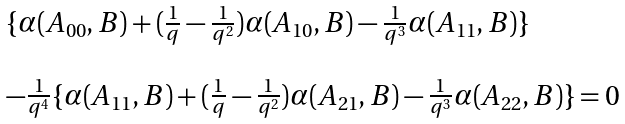<formula> <loc_0><loc_0><loc_500><loc_500>\begin{array} { l } \{ \alpha ( A _ { 0 0 } , B ) + ( \frac { 1 } { q } - \frac { 1 } { q ^ { 2 } } ) \alpha ( A _ { 1 0 } , B ) - \frac { 1 } { q ^ { 3 } } \alpha ( A _ { 1 1 } , B ) \} \\ \\ - \frac { 1 } { q ^ { 4 } } \{ \alpha ( A _ { 1 1 } , B ) + ( \frac { 1 } { q } - \frac { 1 } { q ^ { 2 } } ) \alpha ( A _ { 2 1 } , B ) - \frac { 1 } { q ^ { 3 } } \alpha ( A _ { 2 2 } , B ) \} = 0 \end{array}</formula> 